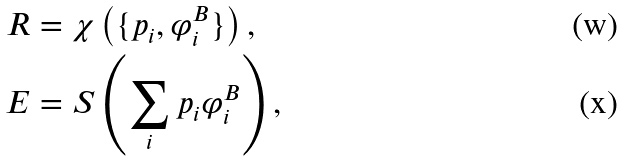Convert formula to latex. <formula><loc_0><loc_0><loc_500><loc_500>R & = \chi \left ( \{ p _ { i } , \varphi _ { i } ^ { B } \} \right ) , \\ E & = S \left ( \sum _ { i } p _ { i } \varphi _ { i } ^ { B } \right ) ,</formula> 